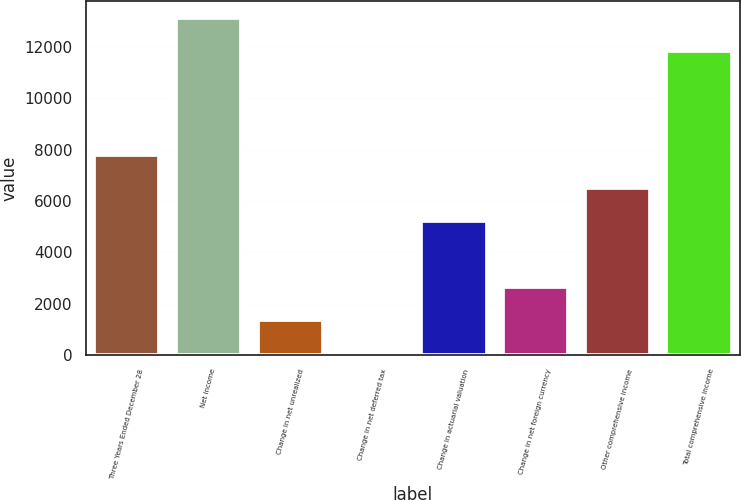Convert chart to OTSL. <chart><loc_0><loc_0><loc_500><loc_500><bar_chart><fcel>Three Years Ended December 28<fcel>Net income<fcel>Change in net unrealized<fcel>Change in net deferred tax<fcel>Change in actuarial valuation<fcel>Change in net foreign currency<fcel>Other comprehensive income<fcel>Total comprehensive income<nl><fcel>7804.8<fcel>13112.3<fcel>1383.3<fcel>99<fcel>5236.2<fcel>2667.6<fcel>6520.5<fcel>11828<nl></chart> 